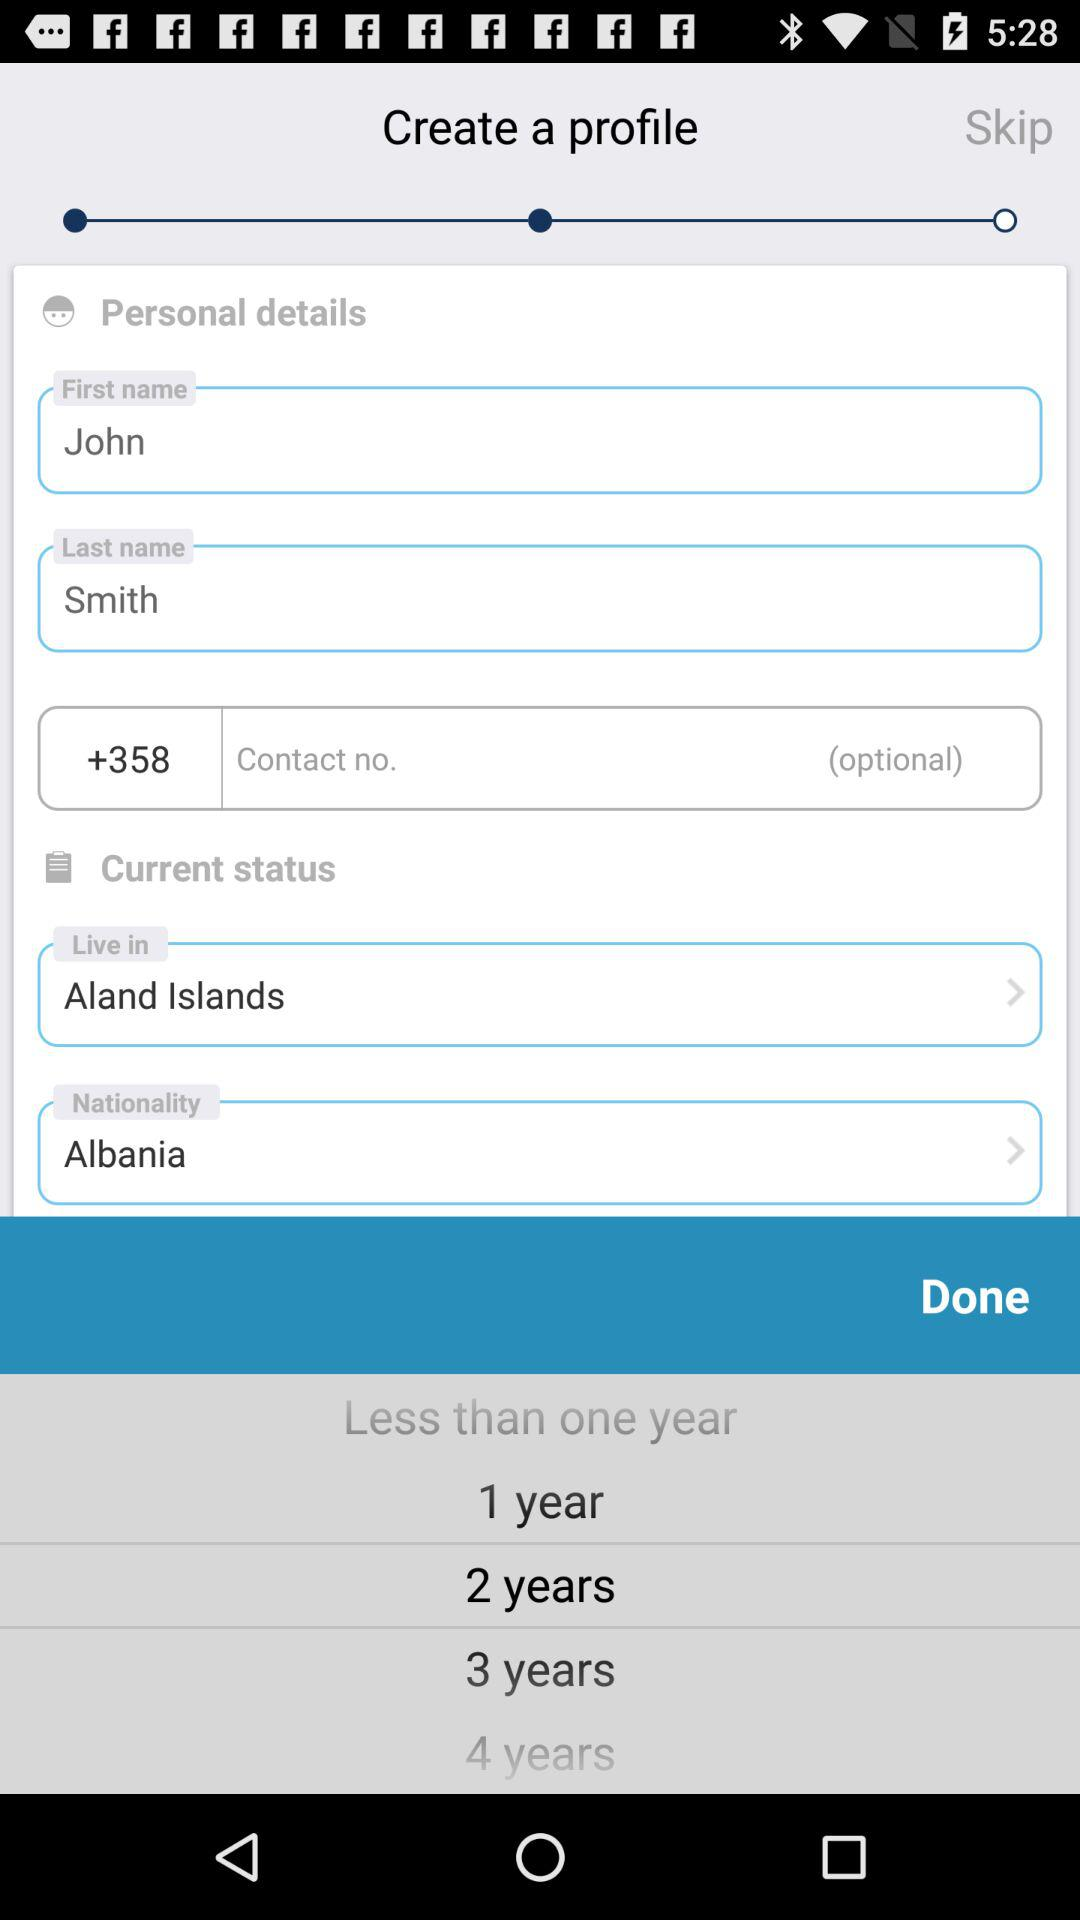What is the country code? The country code is +358. 